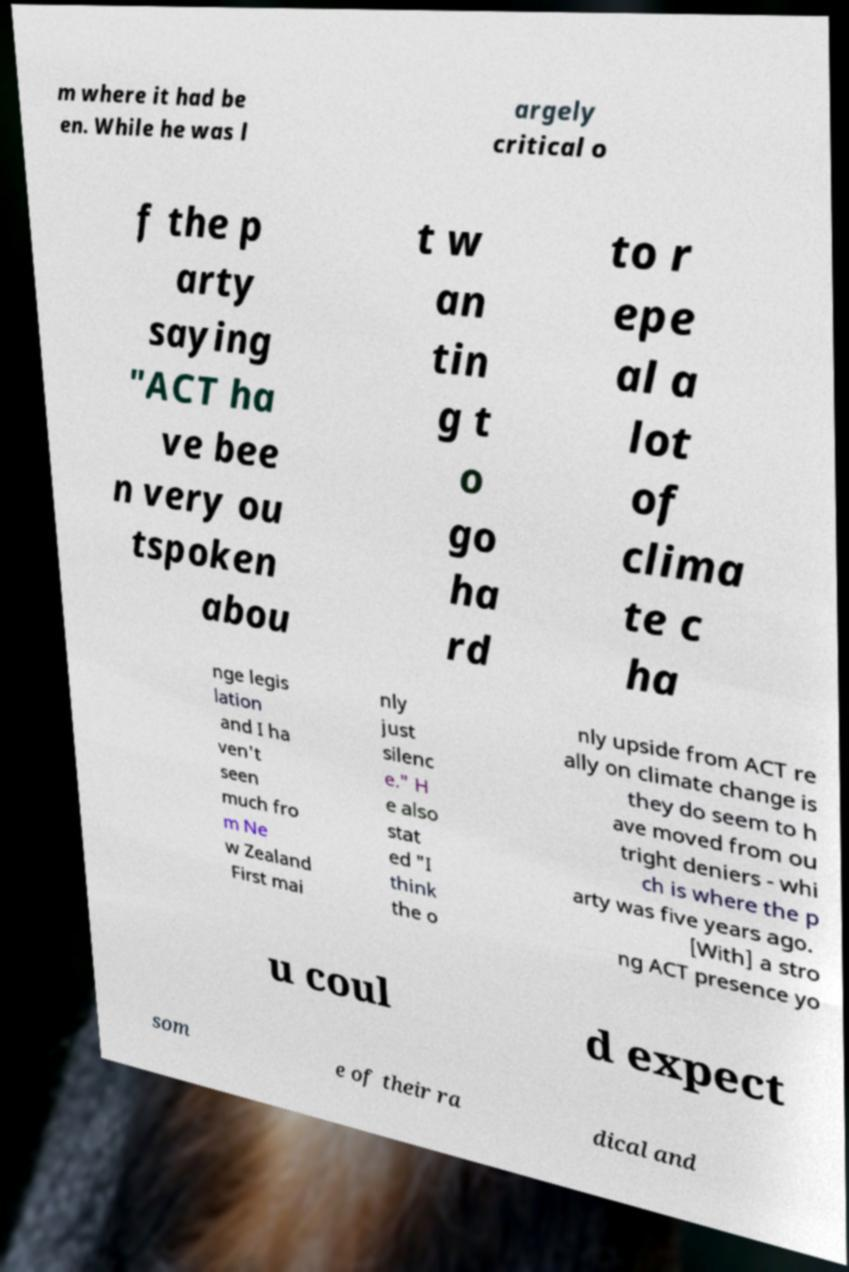Could you extract and type out the text from this image? m where it had be en. While he was l argely critical o f the p arty saying "ACT ha ve bee n very ou tspoken abou t w an tin g t o go ha rd to r epe al a lot of clima te c ha nge legis lation and I ha ven't seen much fro m Ne w Zealand First mai nly just silenc e." H e also stat ed "I think the o nly upside from ACT re ally on climate change is they do seem to h ave moved from ou tright deniers - whi ch is where the p arty was five years ago. [With] a stro ng ACT presence yo u coul d expect som e of their ra dical and 